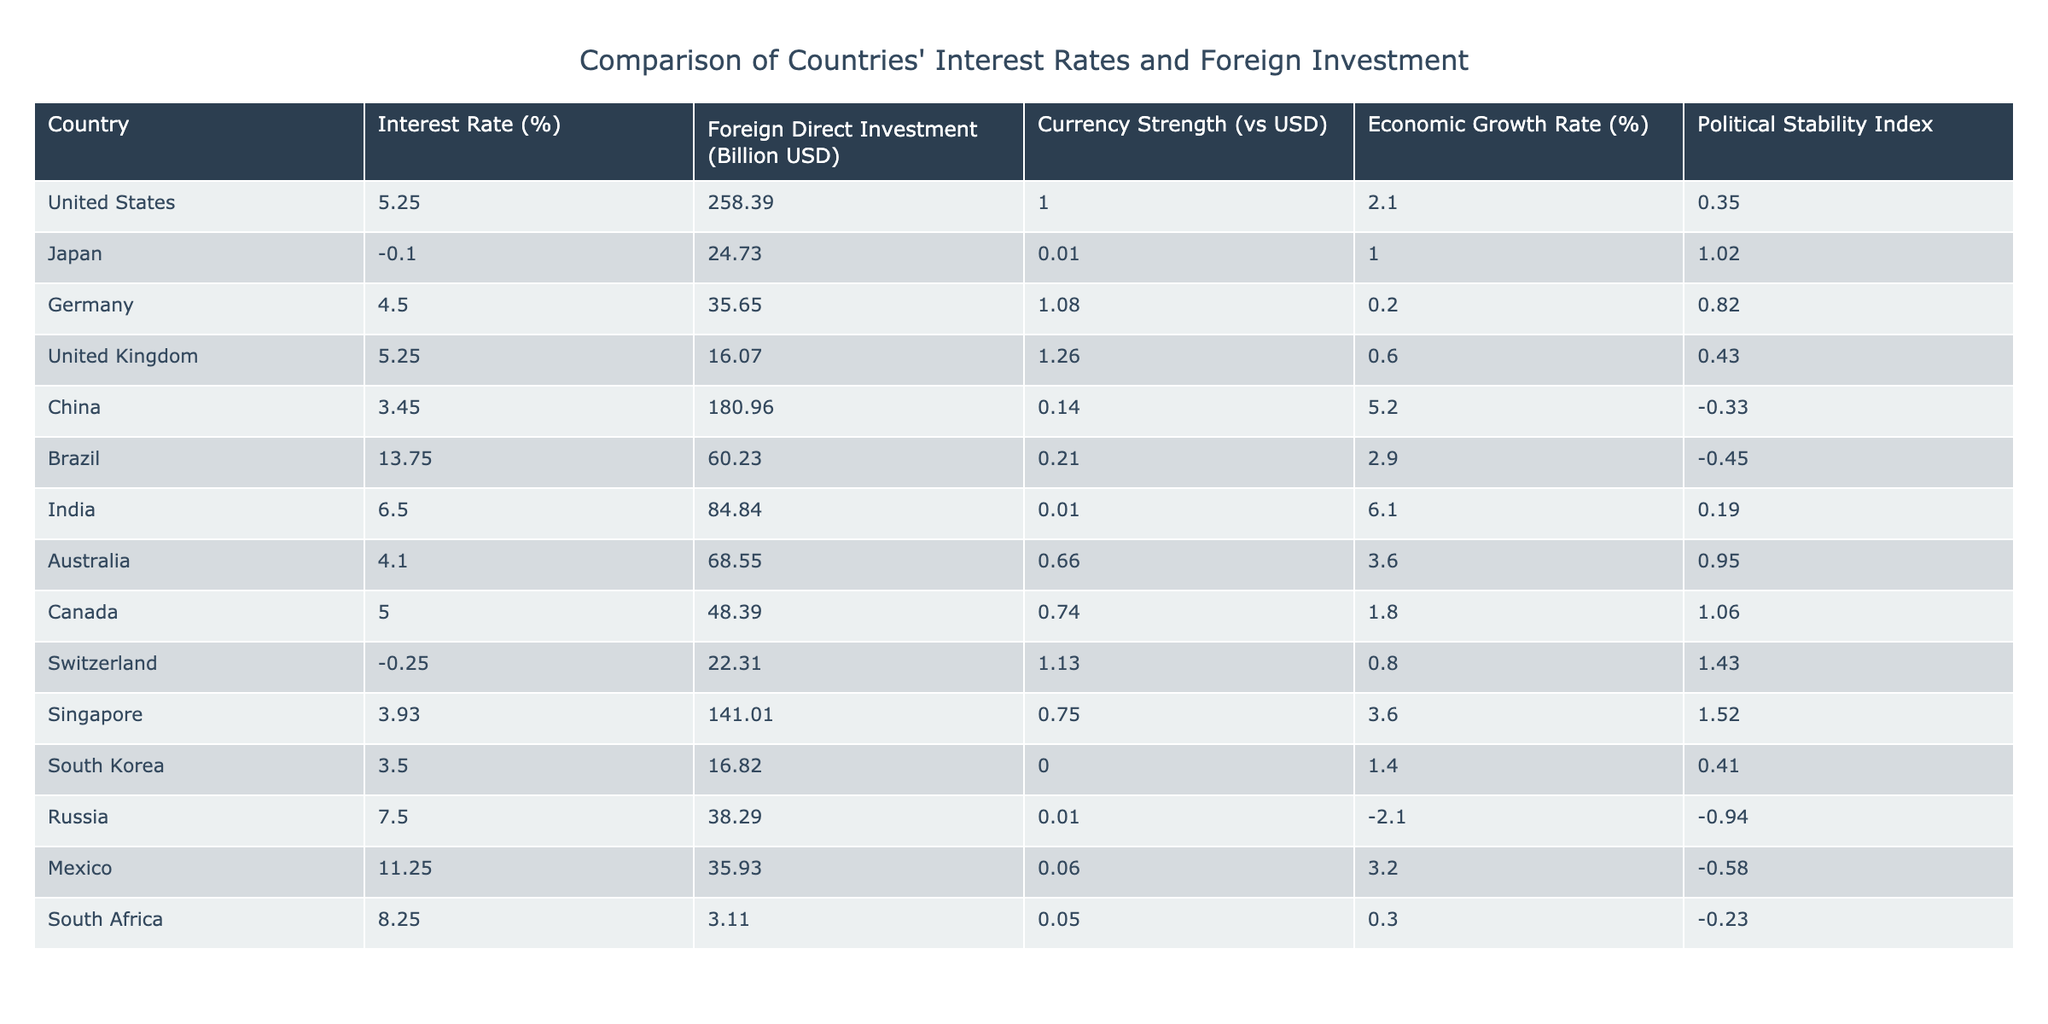What is the highest interest rate presented in the table? The interest rates are listed for each country. Scanning through the values, Brazil has the highest interest rate at 13.75%.
Answer: 13.75% Which country has the lowest foreign direct investment? In the table, the foreign direct investment (FDI) values are provided for each country. Upon inspection, South Africa has the lowest FDI at 3.11 billion USD.
Answer: 3.11 billion USD If we take the average interest rate of the countries listed, what would it be? To calculate the average, sum all the interest rates (5.25 + -0.10 + 4.50 + 5.25 + 3.45 + 13.75 + 6.50 + 4.10 + 5.00 + -0.25 + 3.93 + 3.50 + 7.50 + 11.25 + 8.25) = 3.88 and divide by the total number of countries, which is 15. Therefore, the average interest rate is approximately 3.88%.
Answer: 3.88% Does a higher interest rate correlate with higher foreign direct investment? To evaluate this, look for patterns between the two columns. For example, Brazil has the highest interest rate but a moderate FDI of 60.23 billion USD. Conversely, China has a lower rate of 3.45% but much higher FDI at 180.96 billion USD. Thus, there is no clear correlation indicating that higher interest rates always lead to higher FDI.
Answer: No What is the political stability index of Germany compared to China? Review the political stability index values in the respective rows for Germany and China. Germany has a value of 0.82, while China has a value of -0.33. Comparing the two shows that Germany has a higher political stability index than China.
Answer: Germany's index is higher 